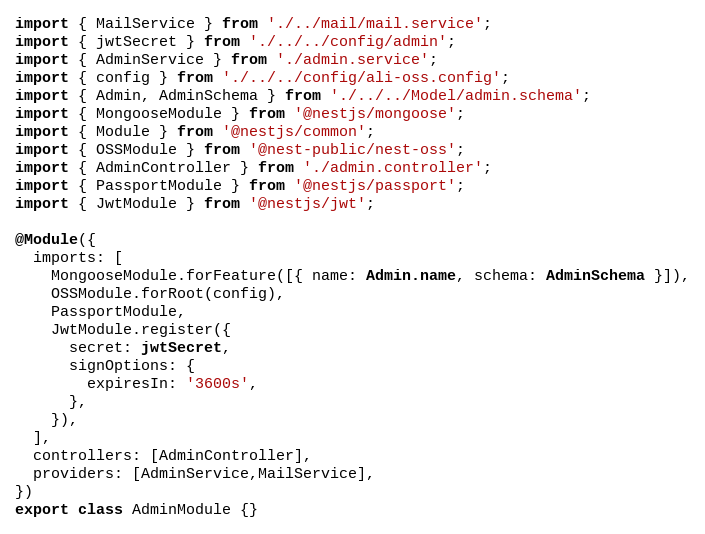Convert code to text. <code><loc_0><loc_0><loc_500><loc_500><_TypeScript_>import { MailService } from './../mail/mail.service';
import { jwtSecret } from './../../config/admin';
import { AdminService } from './admin.service';
import { config } from './../../config/ali-oss.config';
import { Admin, AdminSchema } from './../../Model/admin.schema';
import { MongooseModule } from '@nestjs/mongoose';
import { Module } from '@nestjs/common';
import { OSSModule } from '@nest-public/nest-oss';
import { AdminController } from './admin.controller';
import { PassportModule } from '@nestjs/passport';
import { JwtModule } from '@nestjs/jwt';

@Module({
  imports: [
    MongooseModule.forFeature([{ name: Admin.name, schema: AdminSchema }]),
    OSSModule.forRoot(config),
    PassportModule,
    JwtModule.register({
      secret: jwtSecret,
      signOptions: {
        expiresIn: '3600s',
      },
    }),
  ],
  controllers: [AdminController],
  providers: [AdminService,MailService],
})
export class AdminModule {}
</code> 